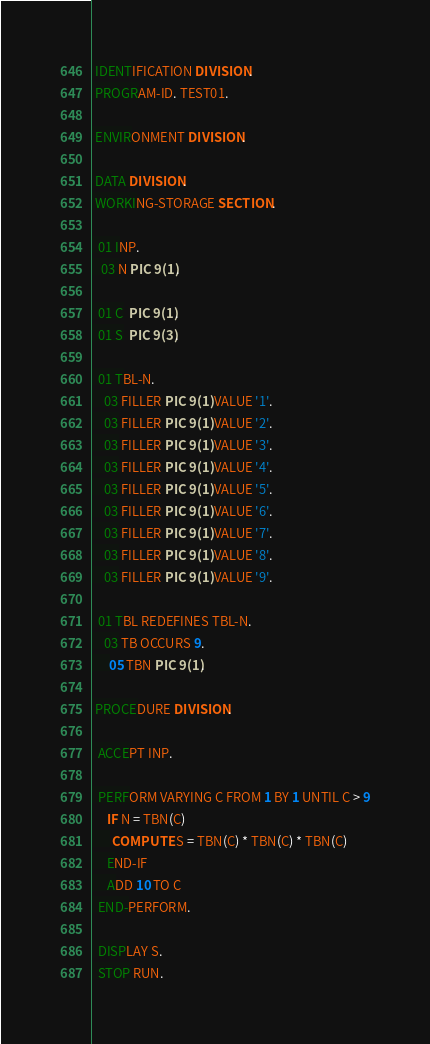<code> <loc_0><loc_0><loc_500><loc_500><_COBOL_> IDENTIFICATION DIVISION.
 PROGRAM-ID. TEST01.

 ENVIRONMENT DIVISION.

 DATA DIVISION.
 WORKING-STORAGE SECTION.

  01 INP.
   03 N PIC 9(1).

  01 C  PIC 9(1).
  01 S  PIC 9(3).

  01 TBL-N.
    03 FILLER PIC 9(1) VALUE '1'.
    03 FILLER PIC 9(1) VALUE '2'.
    03 FILLER PIC 9(1) VALUE '3'.
    03 FILLER PIC 9(1) VALUE '4'.
    03 FILLER PIC 9(1) VALUE '5'.
    03 FILLER PIC 9(1) VALUE '6'.
    03 FILLER PIC 9(1) VALUE '7'.
    03 FILLER PIC 9(1) VALUE '8'.
    03 FILLER PIC 9(1) VALUE '9'.

  01 TBL REDEFINES TBL-N.
    03 TB OCCURS 9.
      05 TBN PIC 9(1).

 PROCEDURE DIVISION.
 
  ACCEPT INP.
 
  PERFORM VARYING C FROM 1 BY 1 UNTIL C > 9
     IF N = TBN(C)
       COMPUTE S = TBN(C) * TBN(C) * TBN(C)
     END-IF
     ADD 10 TO C
  END-PERFORM.

  DISPLAY S.
  STOP RUN. </code> 